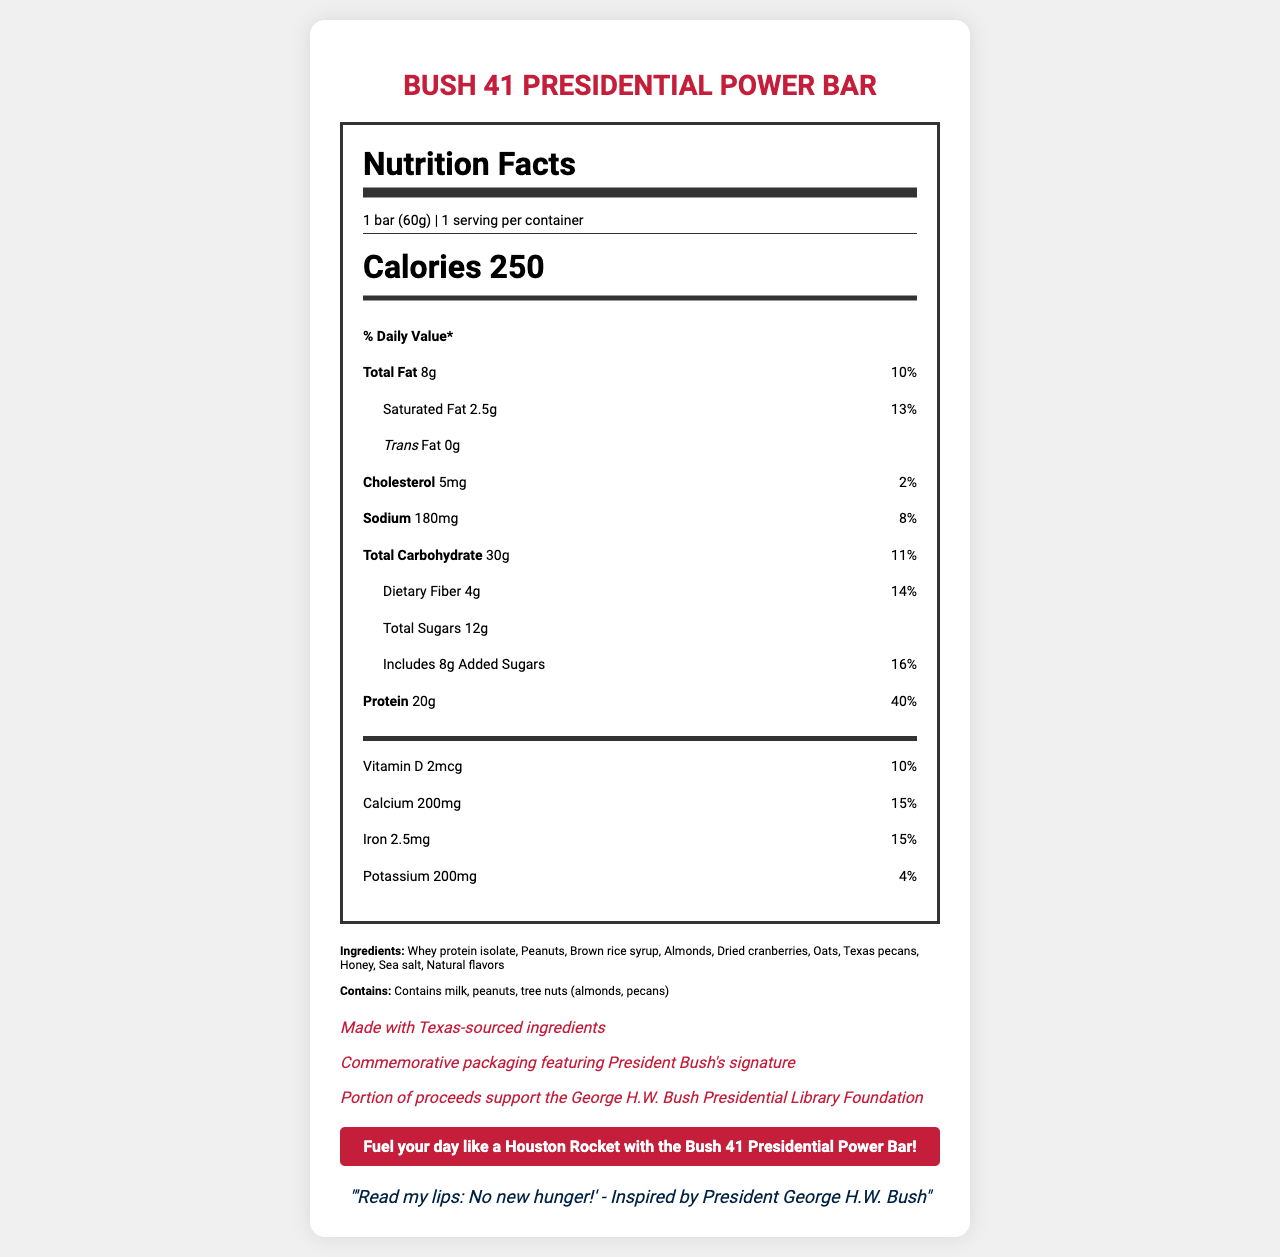What is the serving size of the Bush 41 Presidential Power Bar? The document lists the serving size as "1 bar (60g)" under the serving information.
Answer: 1 bar (60g) How many calories are there in one serving of the Bush 41 Presidential Power Bar? The document states that each serving has 250 calories.
Answer: 250 What is the total amount of protein in the bar? The document indicates that the Bush 41 Presidential Power Bar contains 20g of protein per serving.
Answer: 20g What is the percentage of the daily value for dietary fiber in the Bush 41 Presidential Power Bar? The document states that the dietary fiber content provides 14% of the daily value.
Answer: 14% How much calcium does the bar contain? The nutrition facts list calcium content as 200mg.
Answer: 200mg Which of the following is NOT one of the ingredients in the Bush 41 Presidential Power Bar? A. Oats B. Almonds C. Raisins D. Honey The list of ingredients in the document does not include raisins, but it does include oats, almonds, and honey.
Answer: C. Raisins What percentage of the daily value is provided by the added sugars in the bar? A. 10% B. 16% C. 20% The document lists the daily value percentage for added sugars as 16%.
Answer: B. 16% Does the Bush 41 Presidential Power Bar contain any trans fat? The document states that the bar has 0g of trans fat.
Answer: No Summarize the main features and nutritional information of the Bush 41 Presidential Power Bar. This summary covers the key nutritional facts, ingredients, allergen information, and special features mentioned in the document.
Answer: The Bush 41 Presidential Power Bar is a high-protein snack with 250 calories per serving. It contains 8g of total fat, 2.5g of saturated fat, and 0g of trans fat. It includes 4g of dietary fiber and 12g of total sugars, with 8g of those being added sugars. The bar provides significant amounts of protein (20g), calcium (200mg), iron (2.5mg), and other vitamins and minerals. It is made with Texas-sourced ingredients, features commemorative packaging, and supports the George H.W. Bush Presidential Library Foundation. Allergens include milk, peanuts, and tree nuts. How many servings are there per container? The document states that there is 1 serving per container.
Answer: 1 What is the sodium content in the Bush 41 Presidential Power Bar? The document lists sodium content as 180mg per serving.
Answer: 180mg Are there any tree nuts included in the ingredients? The ingredients list includes almonds and Texas pecans, which are tree nuts.
Answer: Yes What is the special packaging feature mentioned for the Bush 41 Presidential Power Bar? The document mentions this as one of the special features of the bar.
Answer: Commemorative packaging featuring President Bush's signature What is the quote related to President George H.W. Bush mentioned on the label? The document contains this quote inspired by President George H.W. Bush.
Answer: "Read my lips: No new hunger!" Does the Bush 41 Presidential Power Bar claim to have any links with the Houston Rockets? The document contains a claim that says, "Fuel your day like a Houston Rocket with the Bush 41 Presidential Power Bar!"
Answer: Yes What is the recommended daily intake percentage for iron provided by the bar? The document states that the bar provides 15% of the daily value for iron.
Answer: 15% Which Texas-sourced ingredient is included in the bar? The ingredients list includes Texas pecans as one of the components.
Answer: Texas pecans Does the Bush 41 Presidential Power Bar contain gluten? The document does not state if the bar contains gluten or is gluten-free.
Answer: Not enough information What is the total carbohydrate content of the bar? The document states that the total carbohydrate content is 30g.
Answer: 30g 